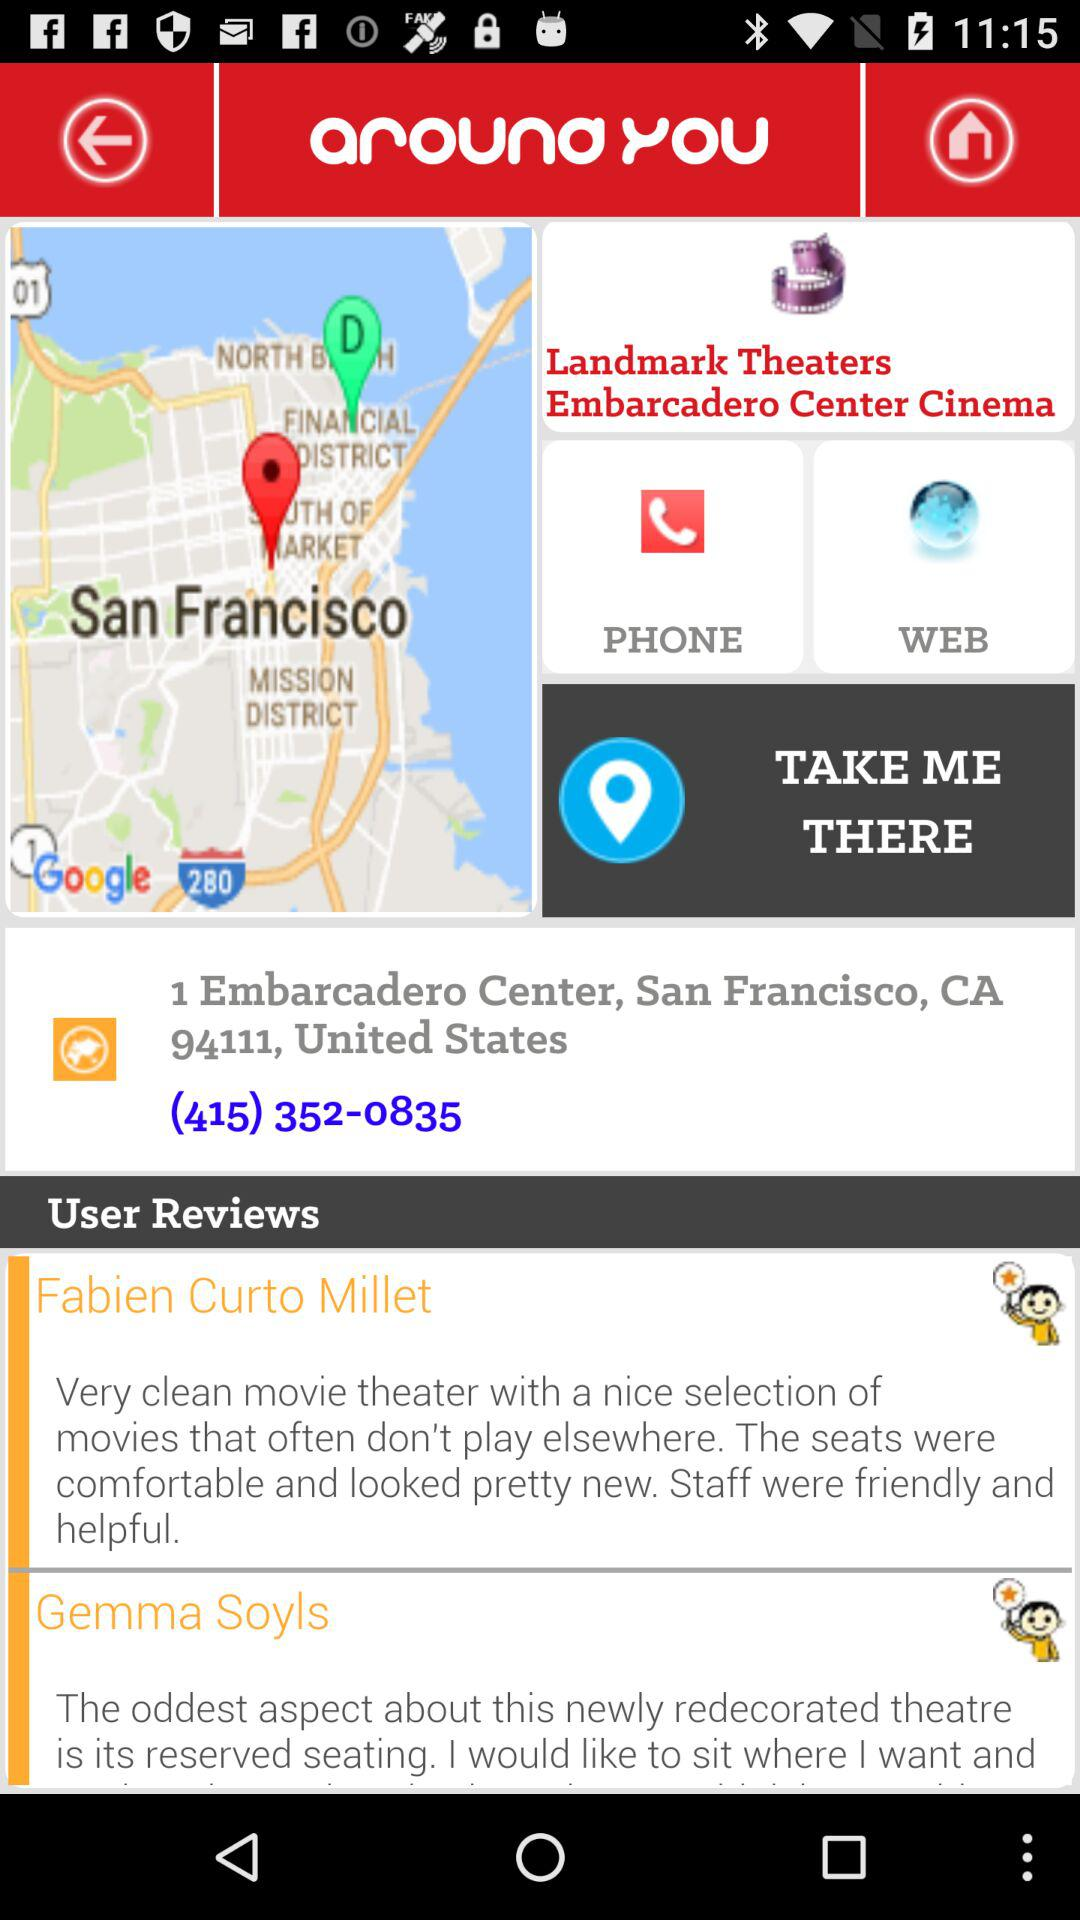What is the phone number? The phone number is (415) 352-0835. 